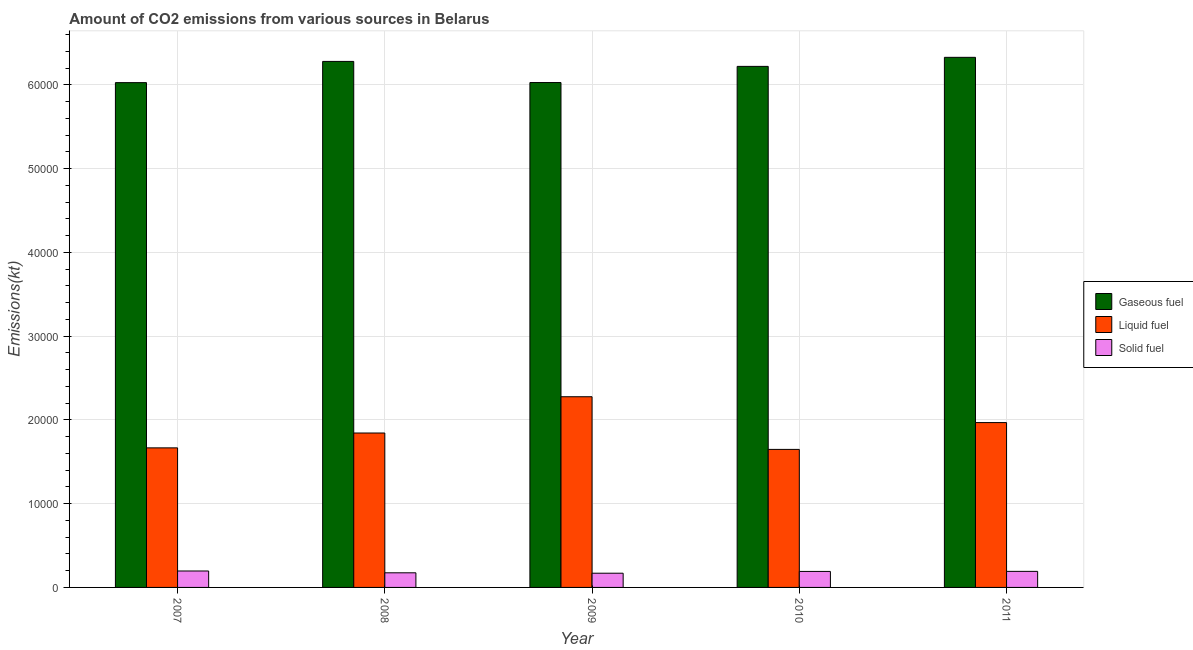How many different coloured bars are there?
Give a very brief answer. 3. How many groups of bars are there?
Offer a very short reply. 5. Are the number of bars per tick equal to the number of legend labels?
Your answer should be very brief. Yes. How many bars are there on the 4th tick from the right?
Keep it short and to the point. 3. What is the label of the 2nd group of bars from the left?
Keep it short and to the point. 2008. In how many cases, is the number of bars for a given year not equal to the number of legend labels?
Make the answer very short. 0. What is the amount of co2 emissions from liquid fuel in 2007?
Make the answer very short. 1.67e+04. Across all years, what is the maximum amount of co2 emissions from solid fuel?
Offer a terse response. 1961.85. Across all years, what is the minimum amount of co2 emissions from gaseous fuel?
Your answer should be very brief. 6.03e+04. In which year was the amount of co2 emissions from solid fuel maximum?
Keep it short and to the point. 2007. In which year was the amount of co2 emissions from liquid fuel minimum?
Provide a succinct answer. 2010. What is the total amount of co2 emissions from gaseous fuel in the graph?
Provide a short and direct response. 3.09e+05. What is the difference between the amount of co2 emissions from liquid fuel in 2008 and that in 2010?
Your response must be concise. 1958.18. What is the difference between the amount of co2 emissions from liquid fuel in 2010 and the amount of co2 emissions from solid fuel in 2007?
Your answer should be very brief. -183.35. What is the average amount of co2 emissions from gaseous fuel per year?
Keep it short and to the point. 6.18e+04. What is the ratio of the amount of co2 emissions from solid fuel in 2008 to that in 2011?
Ensure brevity in your answer.  0.91. Is the amount of co2 emissions from solid fuel in 2008 less than that in 2009?
Give a very brief answer. No. What is the difference between the highest and the second highest amount of co2 emissions from gaseous fuel?
Keep it short and to the point. 487.71. What is the difference between the highest and the lowest amount of co2 emissions from solid fuel?
Provide a succinct answer. 264.02. In how many years, is the amount of co2 emissions from solid fuel greater than the average amount of co2 emissions from solid fuel taken over all years?
Make the answer very short. 3. Is the sum of the amount of co2 emissions from solid fuel in 2007 and 2008 greater than the maximum amount of co2 emissions from gaseous fuel across all years?
Offer a very short reply. Yes. What does the 2nd bar from the left in 2010 represents?
Your response must be concise. Liquid fuel. What does the 3rd bar from the right in 2010 represents?
Offer a very short reply. Gaseous fuel. Is it the case that in every year, the sum of the amount of co2 emissions from gaseous fuel and amount of co2 emissions from liquid fuel is greater than the amount of co2 emissions from solid fuel?
Give a very brief answer. Yes. How many bars are there?
Offer a terse response. 15. Are the values on the major ticks of Y-axis written in scientific E-notation?
Provide a succinct answer. No. What is the title of the graph?
Make the answer very short. Amount of CO2 emissions from various sources in Belarus. What is the label or title of the Y-axis?
Your answer should be compact. Emissions(kt). What is the Emissions(kt) of Gaseous fuel in 2007?
Your answer should be compact. 6.03e+04. What is the Emissions(kt) in Liquid fuel in 2007?
Provide a succinct answer. 1.67e+04. What is the Emissions(kt) in Solid fuel in 2007?
Keep it short and to the point. 1961.85. What is the Emissions(kt) in Gaseous fuel in 2008?
Keep it short and to the point. 6.28e+04. What is the Emissions(kt) of Liquid fuel in 2008?
Provide a succinct answer. 1.84e+04. What is the Emissions(kt) of Solid fuel in 2008?
Provide a succinct answer. 1745.49. What is the Emissions(kt) in Gaseous fuel in 2009?
Your answer should be very brief. 6.03e+04. What is the Emissions(kt) of Liquid fuel in 2009?
Make the answer very short. 2.28e+04. What is the Emissions(kt) of Solid fuel in 2009?
Ensure brevity in your answer.  1697.82. What is the Emissions(kt) of Gaseous fuel in 2010?
Provide a succinct answer. 6.22e+04. What is the Emissions(kt) in Liquid fuel in 2010?
Provide a succinct answer. 1.65e+04. What is the Emissions(kt) in Solid fuel in 2010?
Your response must be concise. 1910.51. What is the Emissions(kt) of Gaseous fuel in 2011?
Offer a terse response. 6.33e+04. What is the Emissions(kt) of Liquid fuel in 2011?
Ensure brevity in your answer.  1.97e+04. What is the Emissions(kt) of Solid fuel in 2011?
Offer a very short reply. 1917.84. Across all years, what is the maximum Emissions(kt) of Gaseous fuel?
Offer a very short reply. 6.33e+04. Across all years, what is the maximum Emissions(kt) in Liquid fuel?
Keep it short and to the point. 2.28e+04. Across all years, what is the maximum Emissions(kt) in Solid fuel?
Make the answer very short. 1961.85. Across all years, what is the minimum Emissions(kt) of Gaseous fuel?
Make the answer very short. 6.03e+04. Across all years, what is the minimum Emissions(kt) of Liquid fuel?
Provide a succinct answer. 1.65e+04. Across all years, what is the minimum Emissions(kt) of Solid fuel?
Your answer should be very brief. 1697.82. What is the total Emissions(kt) in Gaseous fuel in the graph?
Your response must be concise. 3.09e+05. What is the total Emissions(kt) in Liquid fuel in the graph?
Offer a terse response. 9.40e+04. What is the total Emissions(kt) in Solid fuel in the graph?
Offer a terse response. 9233.51. What is the difference between the Emissions(kt) in Gaseous fuel in 2007 and that in 2008?
Make the answer very short. -2533.9. What is the difference between the Emissions(kt) of Liquid fuel in 2007 and that in 2008?
Give a very brief answer. -1774.83. What is the difference between the Emissions(kt) of Solid fuel in 2007 and that in 2008?
Your answer should be compact. 216.35. What is the difference between the Emissions(kt) of Gaseous fuel in 2007 and that in 2009?
Give a very brief answer. -11. What is the difference between the Emissions(kt) in Liquid fuel in 2007 and that in 2009?
Your response must be concise. -6105.56. What is the difference between the Emissions(kt) of Solid fuel in 2007 and that in 2009?
Provide a succinct answer. 264.02. What is the difference between the Emissions(kt) in Gaseous fuel in 2007 and that in 2010?
Ensure brevity in your answer.  -1939.84. What is the difference between the Emissions(kt) of Liquid fuel in 2007 and that in 2010?
Offer a very short reply. 183.35. What is the difference between the Emissions(kt) of Solid fuel in 2007 and that in 2010?
Provide a succinct answer. 51.34. What is the difference between the Emissions(kt) of Gaseous fuel in 2007 and that in 2011?
Your answer should be compact. -3021.61. What is the difference between the Emissions(kt) of Liquid fuel in 2007 and that in 2011?
Your answer should be very brief. -3017.94. What is the difference between the Emissions(kt) of Solid fuel in 2007 and that in 2011?
Make the answer very short. 44. What is the difference between the Emissions(kt) of Gaseous fuel in 2008 and that in 2009?
Make the answer very short. 2522.9. What is the difference between the Emissions(kt) in Liquid fuel in 2008 and that in 2009?
Keep it short and to the point. -4330.73. What is the difference between the Emissions(kt) of Solid fuel in 2008 and that in 2009?
Ensure brevity in your answer.  47.67. What is the difference between the Emissions(kt) in Gaseous fuel in 2008 and that in 2010?
Provide a short and direct response. 594.05. What is the difference between the Emissions(kt) in Liquid fuel in 2008 and that in 2010?
Offer a terse response. 1958.18. What is the difference between the Emissions(kt) in Solid fuel in 2008 and that in 2010?
Your answer should be very brief. -165.01. What is the difference between the Emissions(kt) in Gaseous fuel in 2008 and that in 2011?
Give a very brief answer. -487.71. What is the difference between the Emissions(kt) of Liquid fuel in 2008 and that in 2011?
Your answer should be very brief. -1243.11. What is the difference between the Emissions(kt) of Solid fuel in 2008 and that in 2011?
Provide a short and direct response. -172.35. What is the difference between the Emissions(kt) in Gaseous fuel in 2009 and that in 2010?
Keep it short and to the point. -1928.84. What is the difference between the Emissions(kt) of Liquid fuel in 2009 and that in 2010?
Your answer should be very brief. 6288.9. What is the difference between the Emissions(kt) of Solid fuel in 2009 and that in 2010?
Provide a short and direct response. -212.69. What is the difference between the Emissions(kt) in Gaseous fuel in 2009 and that in 2011?
Make the answer very short. -3010.61. What is the difference between the Emissions(kt) of Liquid fuel in 2009 and that in 2011?
Offer a terse response. 3087.61. What is the difference between the Emissions(kt) in Solid fuel in 2009 and that in 2011?
Offer a terse response. -220.02. What is the difference between the Emissions(kt) of Gaseous fuel in 2010 and that in 2011?
Provide a short and direct response. -1081.77. What is the difference between the Emissions(kt) in Liquid fuel in 2010 and that in 2011?
Provide a short and direct response. -3201.29. What is the difference between the Emissions(kt) in Solid fuel in 2010 and that in 2011?
Your answer should be compact. -7.33. What is the difference between the Emissions(kt) in Gaseous fuel in 2007 and the Emissions(kt) in Liquid fuel in 2008?
Provide a short and direct response. 4.18e+04. What is the difference between the Emissions(kt) of Gaseous fuel in 2007 and the Emissions(kt) of Solid fuel in 2008?
Provide a short and direct response. 5.85e+04. What is the difference between the Emissions(kt) in Liquid fuel in 2007 and the Emissions(kt) in Solid fuel in 2008?
Your answer should be compact. 1.49e+04. What is the difference between the Emissions(kt) in Gaseous fuel in 2007 and the Emissions(kt) in Liquid fuel in 2009?
Your answer should be compact. 3.75e+04. What is the difference between the Emissions(kt) of Gaseous fuel in 2007 and the Emissions(kt) of Solid fuel in 2009?
Make the answer very short. 5.86e+04. What is the difference between the Emissions(kt) in Liquid fuel in 2007 and the Emissions(kt) in Solid fuel in 2009?
Give a very brief answer. 1.50e+04. What is the difference between the Emissions(kt) of Gaseous fuel in 2007 and the Emissions(kt) of Liquid fuel in 2010?
Your answer should be compact. 4.38e+04. What is the difference between the Emissions(kt) in Gaseous fuel in 2007 and the Emissions(kt) in Solid fuel in 2010?
Give a very brief answer. 5.84e+04. What is the difference between the Emissions(kt) of Liquid fuel in 2007 and the Emissions(kt) of Solid fuel in 2010?
Keep it short and to the point. 1.48e+04. What is the difference between the Emissions(kt) of Gaseous fuel in 2007 and the Emissions(kt) of Liquid fuel in 2011?
Make the answer very short. 4.06e+04. What is the difference between the Emissions(kt) of Gaseous fuel in 2007 and the Emissions(kt) of Solid fuel in 2011?
Offer a very short reply. 5.84e+04. What is the difference between the Emissions(kt) of Liquid fuel in 2007 and the Emissions(kt) of Solid fuel in 2011?
Give a very brief answer. 1.47e+04. What is the difference between the Emissions(kt) in Gaseous fuel in 2008 and the Emissions(kt) in Liquid fuel in 2009?
Your answer should be compact. 4.00e+04. What is the difference between the Emissions(kt) of Gaseous fuel in 2008 and the Emissions(kt) of Solid fuel in 2009?
Offer a very short reply. 6.11e+04. What is the difference between the Emissions(kt) of Liquid fuel in 2008 and the Emissions(kt) of Solid fuel in 2009?
Offer a very short reply. 1.67e+04. What is the difference between the Emissions(kt) in Gaseous fuel in 2008 and the Emissions(kt) in Liquid fuel in 2010?
Your answer should be very brief. 4.63e+04. What is the difference between the Emissions(kt) in Gaseous fuel in 2008 and the Emissions(kt) in Solid fuel in 2010?
Make the answer very short. 6.09e+04. What is the difference between the Emissions(kt) of Liquid fuel in 2008 and the Emissions(kt) of Solid fuel in 2010?
Ensure brevity in your answer.  1.65e+04. What is the difference between the Emissions(kt) of Gaseous fuel in 2008 and the Emissions(kt) of Liquid fuel in 2011?
Your response must be concise. 4.31e+04. What is the difference between the Emissions(kt) in Gaseous fuel in 2008 and the Emissions(kt) in Solid fuel in 2011?
Your answer should be very brief. 6.09e+04. What is the difference between the Emissions(kt) of Liquid fuel in 2008 and the Emissions(kt) of Solid fuel in 2011?
Give a very brief answer. 1.65e+04. What is the difference between the Emissions(kt) of Gaseous fuel in 2009 and the Emissions(kt) of Liquid fuel in 2010?
Give a very brief answer. 4.38e+04. What is the difference between the Emissions(kt) of Gaseous fuel in 2009 and the Emissions(kt) of Solid fuel in 2010?
Offer a terse response. 5.84e+04. What is the difference between the Emissions(kt) in Liquid fuel in 2009 and the Emissions(kt) in Solid fuel in 2010?
Your answer should be compact. 2.09e+04. What is the difference between the Emissions(kt) in Gaseous fuel in 2009 and the Emissions(kt) in Liquid fuel in 2011?
Your response must be concise. 4.06e+04. What is the difference between the Emissions(kt) of Gaseous fuel in 2009 and the Emissions(kt) of Solid fuel in 2011?
Provide a succinct answer. 5.84e+04. What is the difference between the Emissions(kt) in Liquid fuel in 2009 and the Emissions(kt) in Solid fuel in 2011?
Your response must be concise. 2.09e+04. What is the difference between the Emissions(kt) of Gaseous fuel in 2010 and the Emissions(kt) of Liquid fuel in 2011?
Keep it short and to the point. 4.25e+04. What is the difference between the Emissions(kt) in Gaseous fuel in 2010 and the Emissions(kt) in Solid fuel in 2011?
Your response must be concise. 6.03e+04. What is the difference between the Emissions(kt) of Liquid fuel in 2010 and the Emissions(kt) of Solid fuel in 2011?
Provide a succinct answer. 1.46e+04. What is the average Emissions(kt) in Gaseous fuel per year?
Offer a very short reply. 6.18e+04. What is the average Emissions(kt) of Liquid fuel per year?
Your answer should be very brief. 1.88e+04. What is the average Emissions(kt) of Solid fuel per year?
Provide a succinct answer. 1846.7. In the year 2007, what is the difference between the Emissions(kt) in Gaseous fuel and Emissions(kt) in Liquid fuel?
Your answer should be very brief. 4.36e+04. In the year 2007, what is the difference between the Emissions(kt) in Gaseous fuel and Emissions(kt) in Solid fuel?
Offer a terse response. 5.83e+04. In the year 2007, what is the difference between the Emissions(kt) in Liquid fuel and Emissions(kt) in Solid fuel?
Keep it short and to the point. 1.47e+04. In the year 2008, what is the difference between the Emissions(kt) in Gaseous fuel and Emissions(kt) in Liquid fuel?
Provide a short and direct response. 4.44e+04. In the year 2008, what is the difference between the Emissions(kt) in Gaseous fuel and Emissions(kt) in Solid fuel?
Provide a short and direct response. 6.11e+04. In the year 2008, what is the difference between the Emissions(kt) in Liquid fuel and Emissions(kt) in Solid fuel?
Offer a terse response. 1.67e+04. In the year 2009, what is the difference between the Emissions(kt) in Gaseous fuel and Emissions(kt) in Liquid fuel?
Your answer should be very brief. 3.75e+04. In the year 2009, what is the difference between the Emissions(kt) in Gaseous fuel and Emissions(kt) in Solid fuel?
Provide a short and direct response. 5.86e+04. In the year 2009, what is the difference between the Emissions(kt) of Liquid fuel and Emissions(kt) of Solid fuel?
Your answer should be very brief. 2.11e+04. In the year 2010, what is the difference between the Emissions(kt) of Gaseous fuel and Emissions(kt) of Liquid fuel?
Your answer should be very brief. 4.57e+04. In the year 2010, what is the difference between the Emissions(kt) of Gaseous fuel and Emissions(kt) of Solid fuel?
Give a very brief answer. 6.03e+04. In the year 2010, what is the difference between the Emissions(kt) of Liquid fuel and Emissions(kt) of Solid fuel?
Offer a very short reply. 1.46e+04. In the year 2011, what is the difference between the Emissions(kt) of Gaseous fuel and Emissions(kt) of Liquid fuel?
Your response must be concise. 4.36e+04. In the year 2011, what is the difference between the Emissions(kt) of Gaseous fuel and Emissions(kt) of Solid fuel?
Give a very brief answer. 6.14e+04. In the year 2011, what is the difference between the Emissions(kt) of Liquid fuel and Emissions(kt) of Solid fuel?
Ensure brevity in your answer.  1.78e+04. What is the ratio of the Emissions(kt) in Gaseous fuel in 2007 to that in 2008?
Give a very brief answer. 0.96. What is the ratio of the Emissions(kt) of Liquid fuel in 2007 to that in 2008?
Give a very brief answer. 0.9. What is the ratio of the Emissions(kt) of Solid fuel in 2007 to that in 2008?
Give a very brief answer. 1.12. What is the ratio of the Emissions(kt) in Liquid fuel in 2007 to that in 2009?
Ensure brevity in your answer.  0.73. What is the ratio of the Emissions(kt) of Solid fuel in 2007 to that in 2009?
Your answer should be compact. 1.16. What is the ratio of the Emissions(kt) of Gaseous fuel in 2007 to that in 2010?
Make the answer very short. 0.97. What is the ratio of the Emissions(kt) of Liquid fuel in 2007 to that in 2010?
Your answer should be compact. 1.01. What is the ratio of the Emissions(kt) in Solid fuel in 2007 to that in 2010?
Keep it short and to the point. 1.03. What is the ratio of the Emissions(kt) in Gaseous fuel in 2007 to that in 2011?
Ensure brevity in your answer.  0.95. What is the ratio of the Emissions(kt) of Liquid fuel in 2007 to that in 2011?
Your answer should be compact. 0.85. What is the ratio of the Emissions(kt) in Solid fuel in 2007 to that in 2011?
Your answer should be compact. 1.02. What is the ratio of the Emissions(kt) of Gaseous fuel in 2008 to that in 2009?
Keep it short and to the point. 1.04. What is the ratio of the Emissions(kt) of Liquid fuel in 2008 to that in 2009?
Provide a short and direct response. 0.81. What is the ratio of the Emissions(kt) of Solid fuel in 2008 to that in 2009?
Give a very brief answer. 1.03. What is the ratio of the Emissions(kt) in Gaseous fuel in 2008 to that in 2010?
Your response must be concise. 1.01. What is the ratio of the Emissions(kt) of Liquid fuel in 2008 to that in 2010?
Give a very brief answer. 1.12. What is the ratio of the Emissions(kt) of Solid fuel in 2008 to that in 2010?
Offer a very short reply. 0.91. What is the ratio of the Emissions(kt) of Gaseous fuel in 2008 to that in 2011?
Keep it short and to the point. 0.99. What is the ratio of the Emissions(kt) of Liquid fuel in 2008 to that in 2011?
Provide a succinct answer. 0.94. What is the ratio of the Emissions(kt) of Solid fuel in 2008 to that in 2011?
Give a very brief answer. 0.91. What is the ratio of the Emissions(kt) of Liquid fuel in 2009 to that in 2010?
Offer a very short reply. 1.38. What is the ratio of the Emissions(kt) of Solid fuel in 2009 to that in 2010?
Keep it short and to the point. 0.89. What is the ratio of the Emissions(kt) in Liquid fuel in 2009 to that in 2011?
Give a very brief answer. 1.16. What is the ratio of the Emissions(kt) of Solid fuel in 2009 to that in 2011?
Your answer should be compact. 0.89. What is the ratio of the Emissions(kt) in Gaseous fuel in 2010 to that in 2011?
Offer a very short reply. 0.98. What is the ratio of the Emissions(kt) in Liquid fuel in 2010 to that in 2011?
Your response must be concise. 0.84. What is the ratio of the Emissions(kt) of Solid fuel in 2010 to that in 2011?
Offer a terse response. 1. What is the difference between the highest and the second highest Emissions(kt) in Gaseous fuel?
Keep it short and to the point. 487.71. What is the difference between the highest and the second highest Emissions(kt) of Liquid fuel?
Give a very brief answer. 3087.61. What is the difference between the highest and the second highest Emissions(kt) of Solid fuel?
Make the answer very short. 44. What is the difference between the highest and the lowest Emissions(kt) of Gaseous fuel?
Your answer should be very brief. 3021.61. What is the difference between the highest and the lowest Emissions(kt) in Liquid fuel?
Give a very brief answer. 6288.9. What is the difference between the highest and the lowest Emissions(kt) of Solid fuel?
Your answer should be very brief. 264.02. 